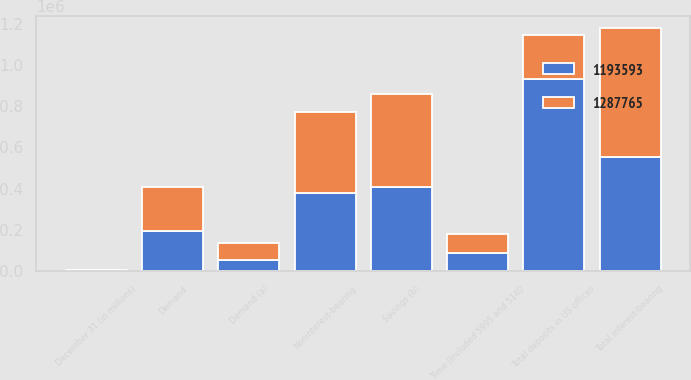<chart> <loc_0><loc_0><loc_500><loc_500><stacked_bar_chart><ecel><fcel>December 31 (in millions)<fcel>Noninterest-bearing<fcel>Demand (a)<fcel>Savings (b)<fcel>Time (included 5995 and 5140<fcel>Total interest-bearing<fcel>Total deposits in US offices<fcel>Demand<nl><fcel>1.28776e+06<fcel>2013<fcel>389863<fcel>84631<fcel>450405<fcel>91356<fcel>626392<fcel>214391<fcel>214391<nl><fcel>1.19359e+06<fcel>2012<fcel>380320<fcel>53980<fcel>407710<fcel>90416<fcel>552106<fcel>932426<fcel>195395<nl></chart> 